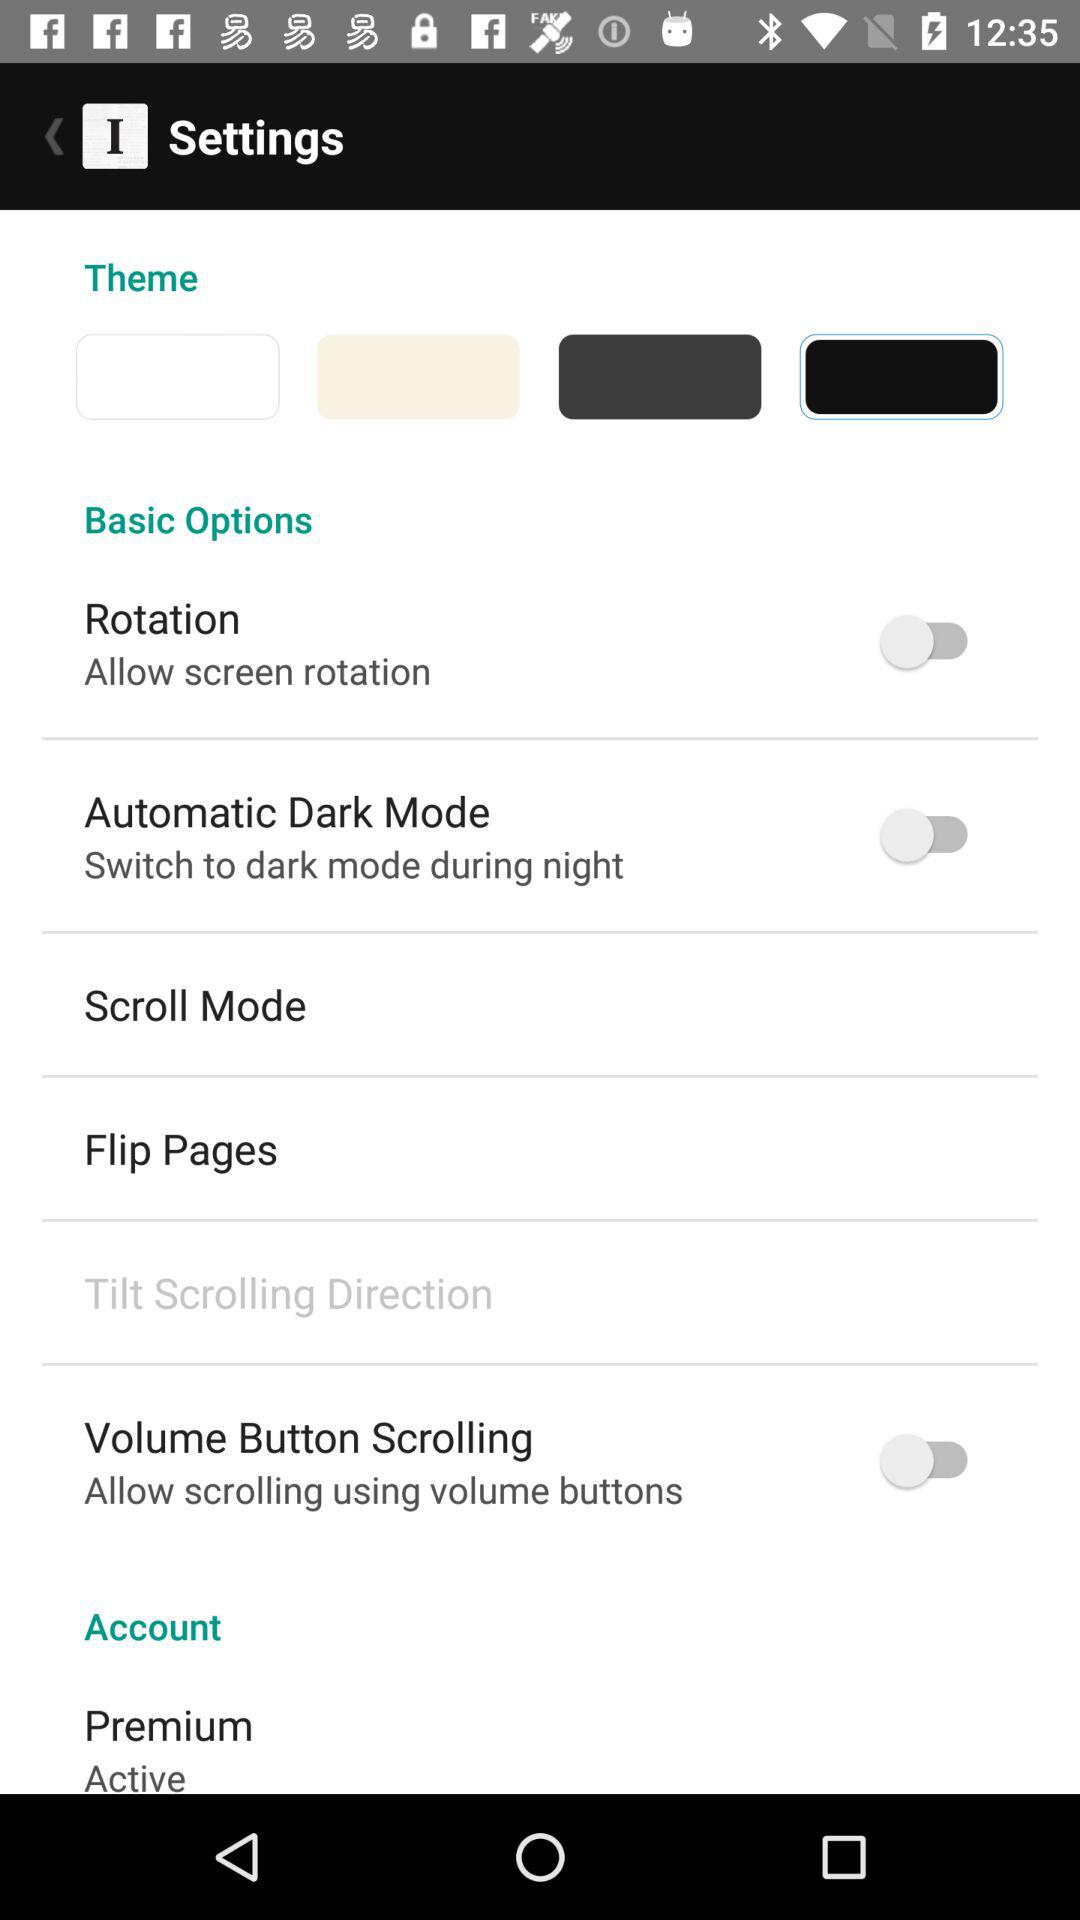What is the setting for "Premium"? The setting for "Premium" is "Active". 